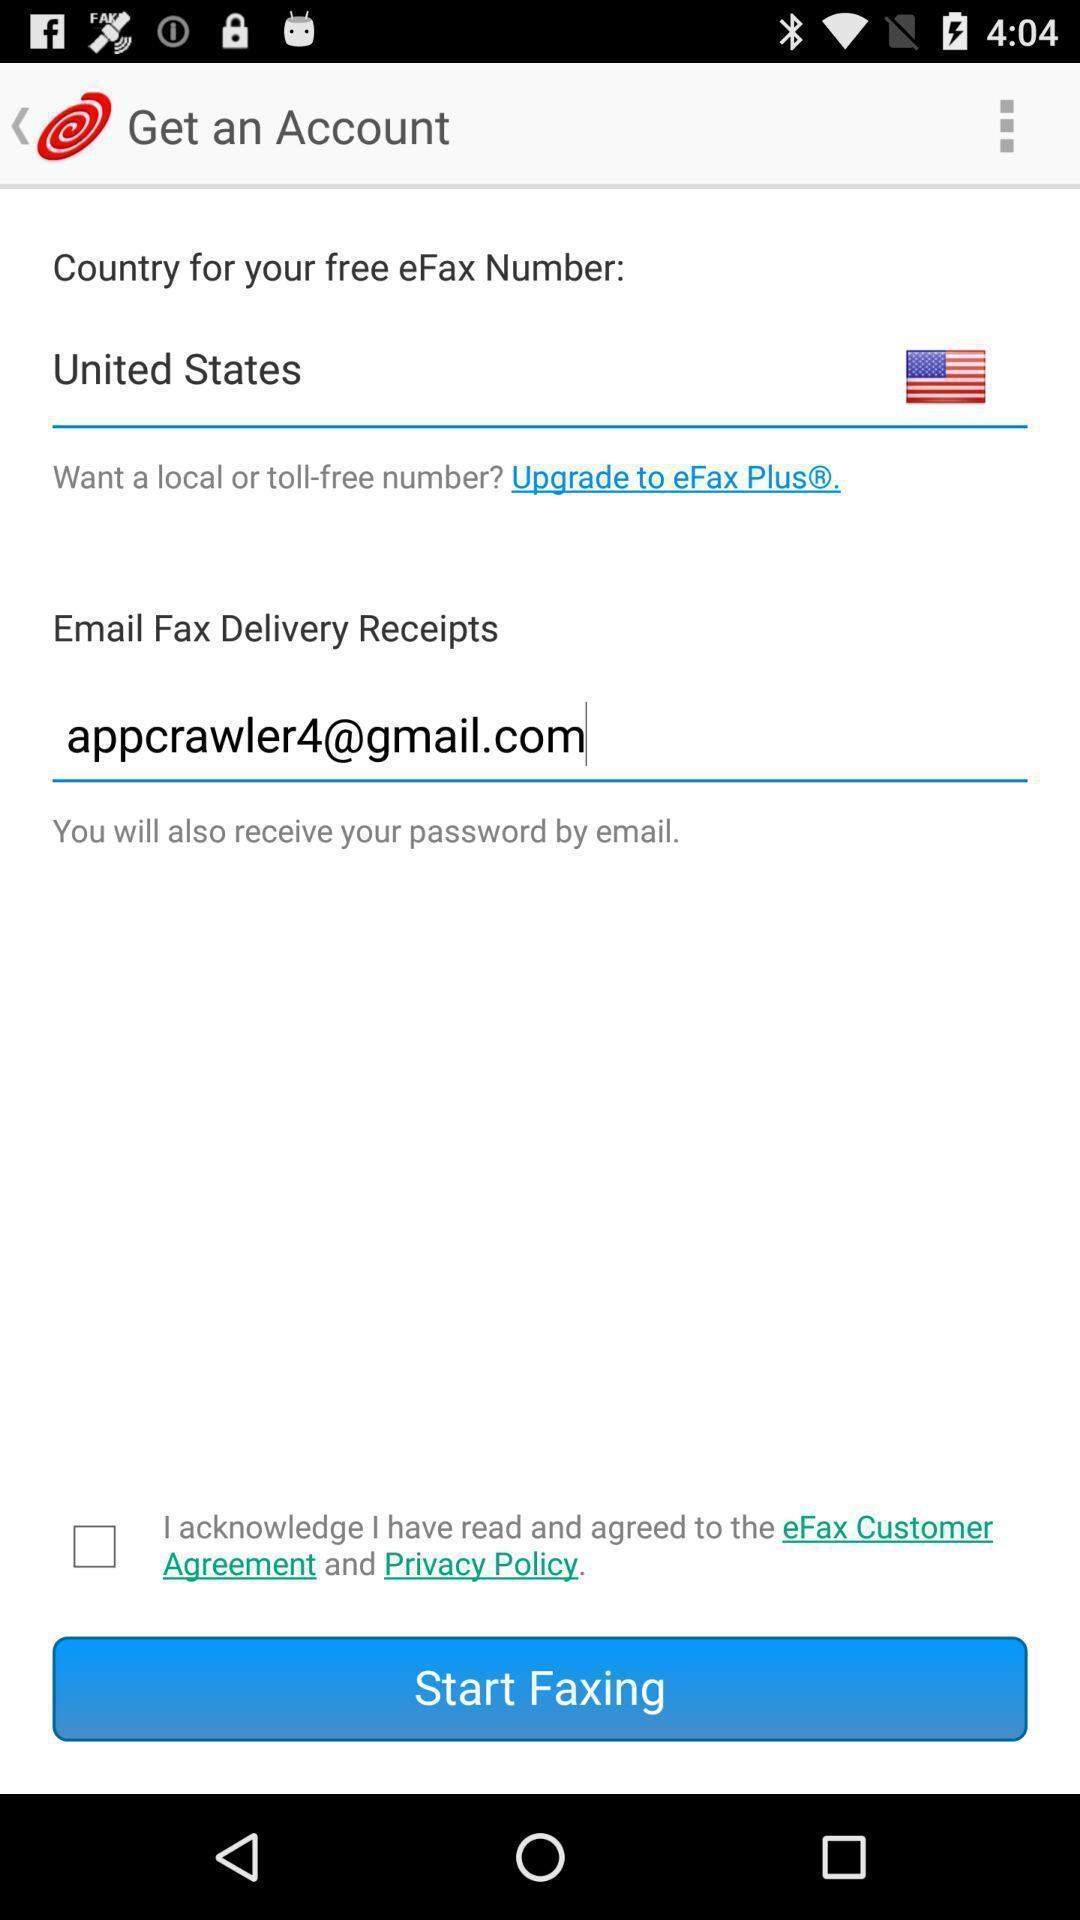What is the overall content of this screenshot? Screen showing get an account. 